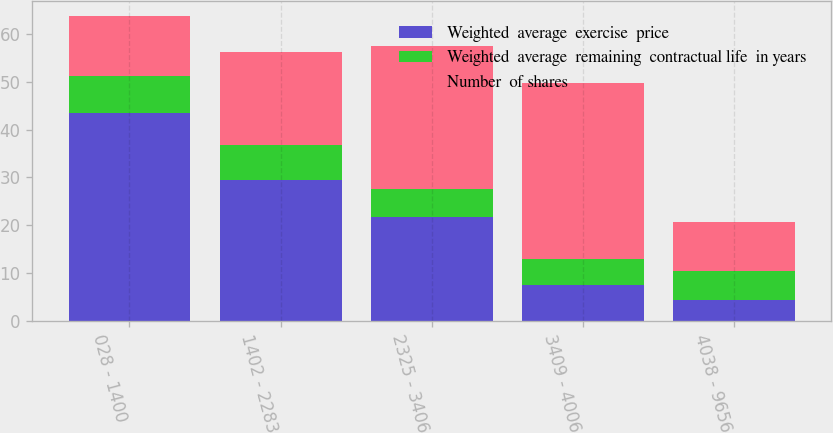Convert chart to OTSL. <chart><loc_0><loc_0><loc_500><loc_500><stacked_bar_chart><ecel><fcel>028 - 1400<fcel>1402 - 2283<fcel>2325 - 3406<fcel>3409 - 4006<fcel>4038 - 9656<nl><fcel>Weighted  average  exercise  price<fcel>43.4<fcel>29.5<fcel>21.6<fcel>7.5<fcel>4.4<nl><fcel>Weighted  average  remaining  contractual life  in years<fcel>7.7<fcel>7.3<fcel>5.9<fcel>5.4<fcel>6.1<nl><fcel>Number  of shares<fcel>12.59<fcel>19.37<fcel>29.94<fcel>36.81<fcel>10.145<nl></chart> 